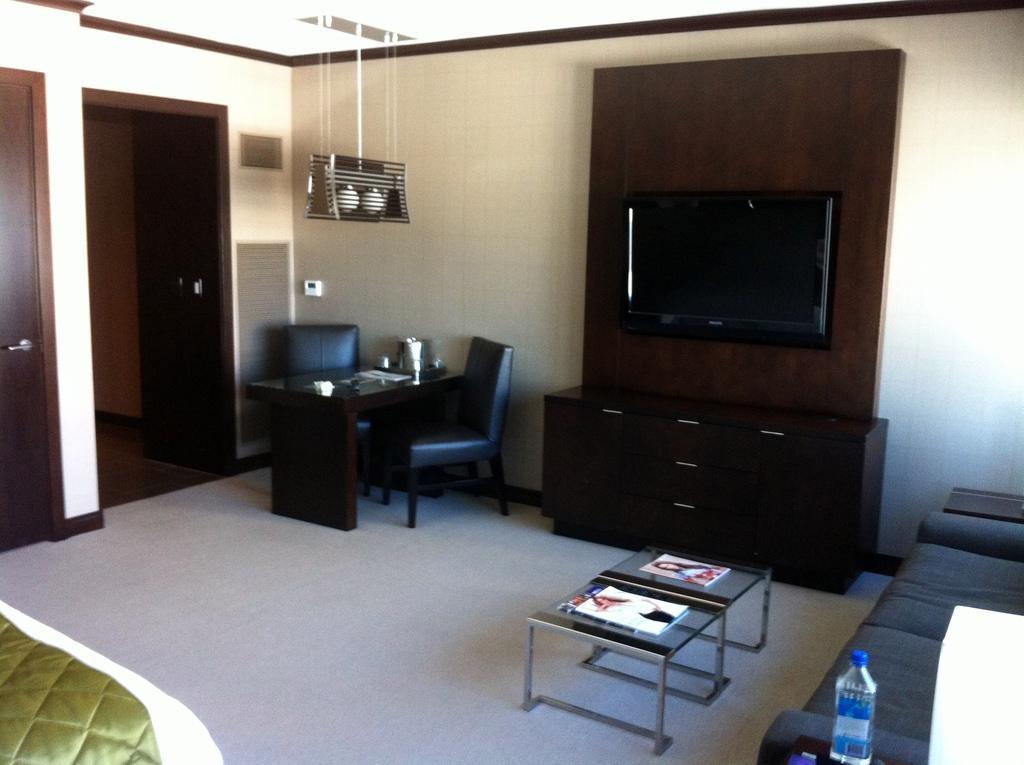Describe this image in one or two sentences. This picture describes about interior of the room, in this we can see a bed, table, chairs, television, sofa and water bottle, and also we can see books on the table. 